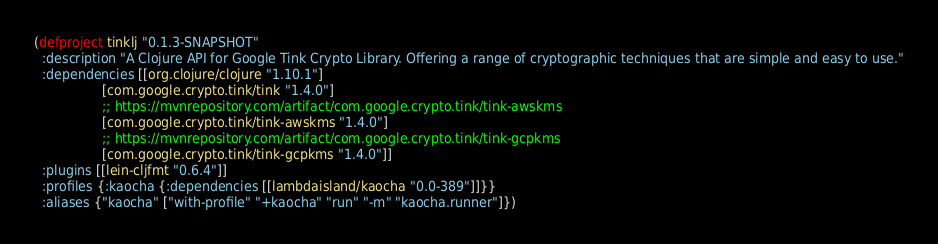<code> <loc_0><loc_0><loc_500><loc_500><_Clojure_>(defproject tinklj "0.1.3-SNAPSHOT"
  :description "A Clojure API for Google Tink Crypto Library. Offering a range of cryptographic techniques that are simple and easy to use."
  :dependencies [[org.clojure/clojure "1.10.1"]
                 [com.google.crypto.tink/tink "1.4.0"]
                 ;; https://mvnrepository.com/artifact/com.google.crypto.tink/tink-awskms
                 [com.google.crypto.tink/tink-awskms "1.4.0"]
                 ;; https://mvnrepository.com/artifact/com.google.crypto.tink/tink-gcpkms
                 [com.google.crypto.tink/tink-gcpkms "1.4.0"]]
  :plugins [[lein-cljfmt "0.6.4"]]
  :profiles {:kaocha {:dependencies [[lambdaisland/kaocha "0.0-389"]]}}
  :aliases {"kaocha" ["with-profile" "+kaocha" "run" "-m" "kaocha.runner"]})
</code> 